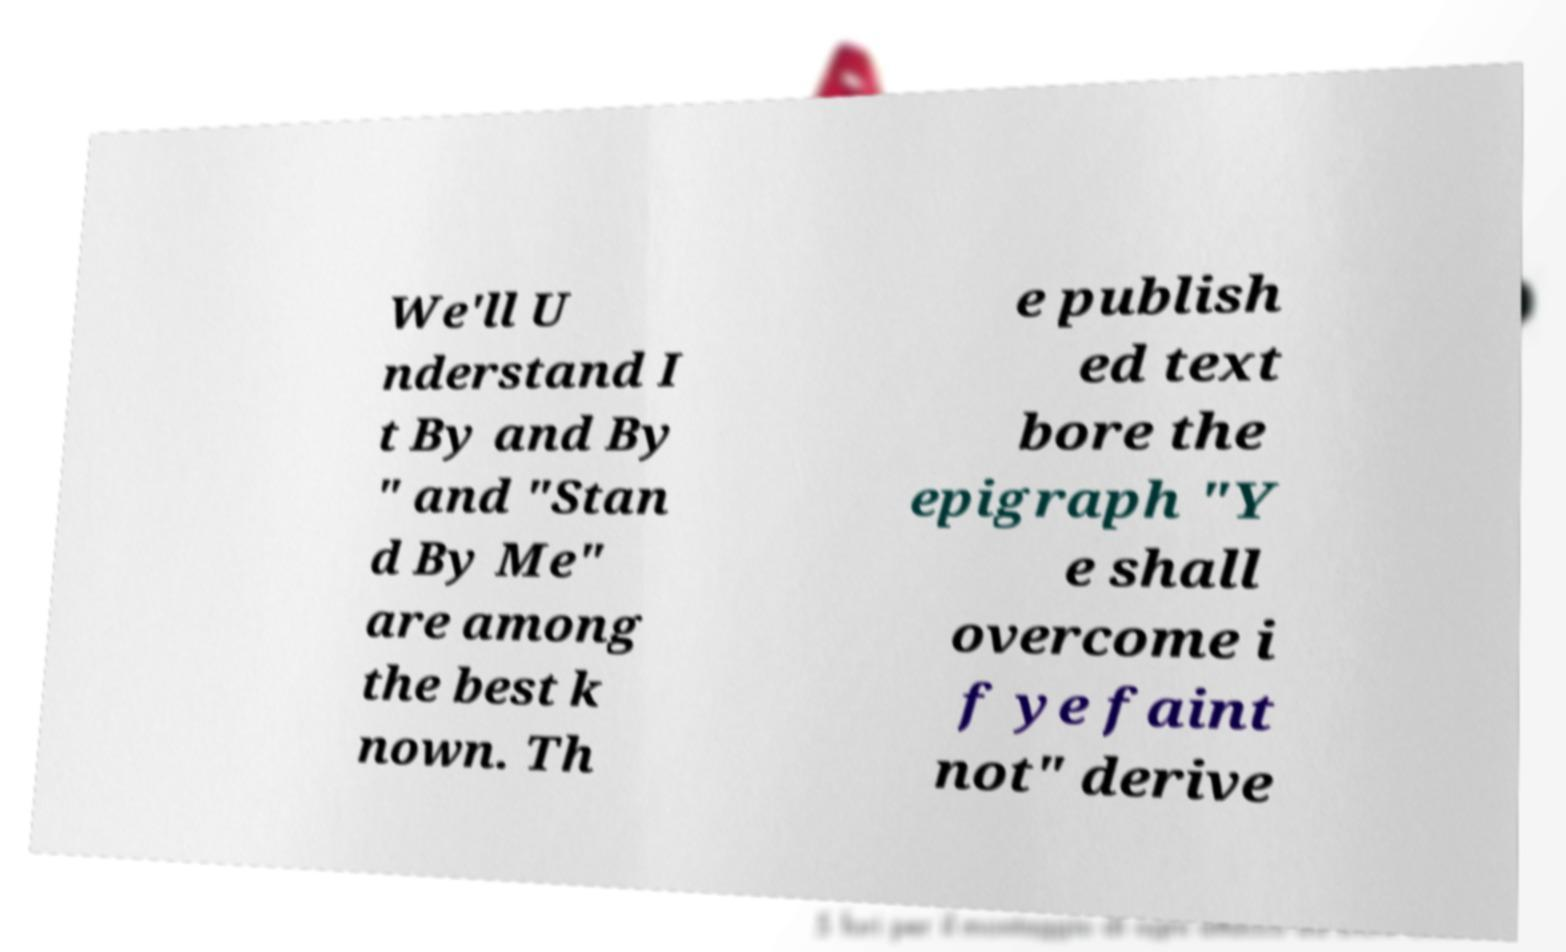Can you accurately transcribe the text from the provided image for me? We'll U nderstand I t By and By " and "Stan d By Me" are among the best k nown. Th e publish ed text bore the epigraph "Y e shall overcome i f ye faint not" derive 